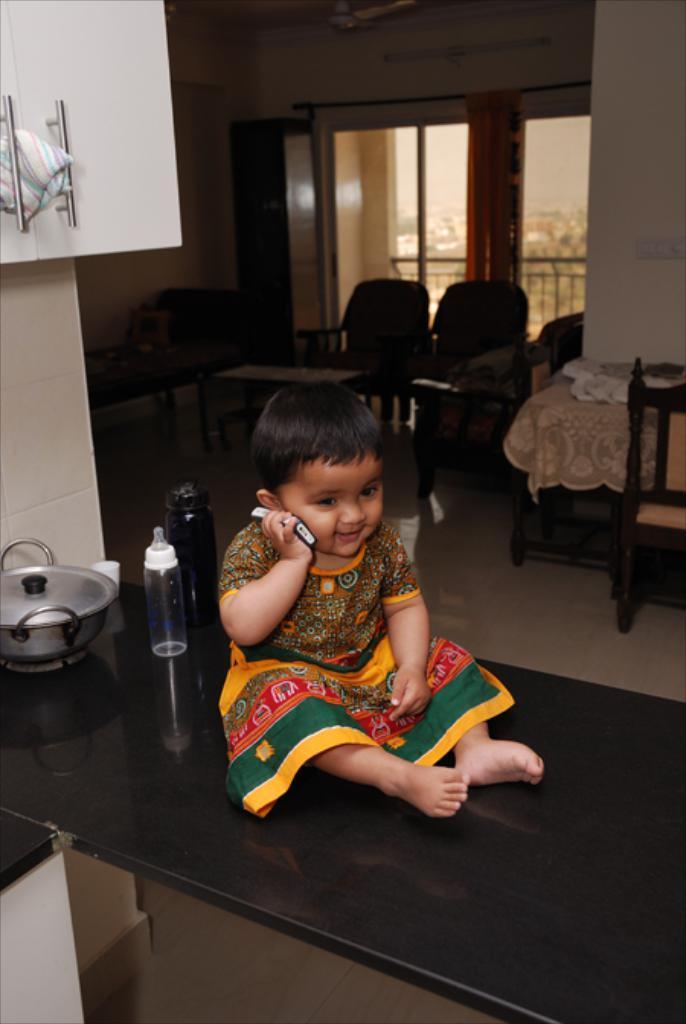How would you summarize this image in a sentence or two? In this picture a girl sitting on a table with a phone in her hands. In the background we observe furniture ,glass window , curtains. There are also few objects kept on the table. 